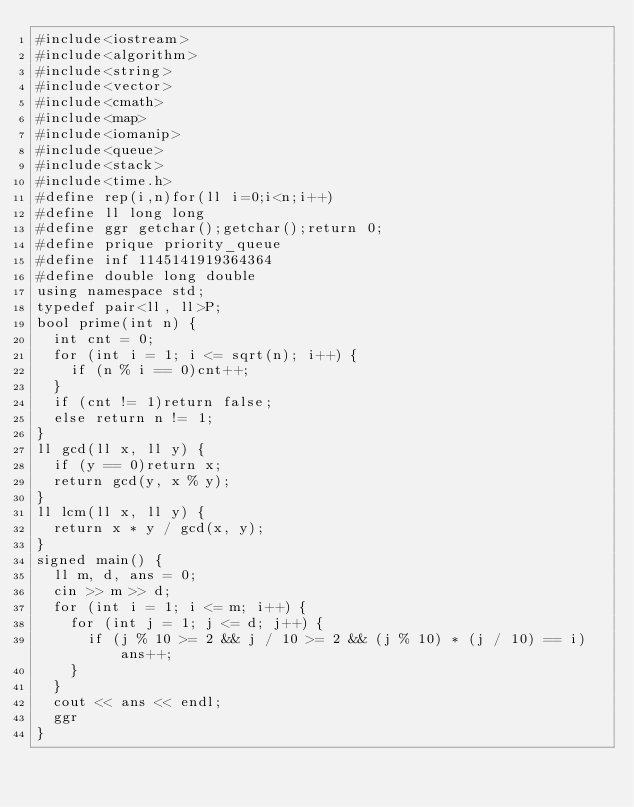<code> <loc_0><loc_0><loc_500><loc_500><_C++_>#include<iostream>
#include<algorithm>
#include<string>
#include<vector>
#include<cmath>
#include<map>
#include<iomanip>
#include<queue>
#include<stack>
#include<time.h>
#define rep(i,n)for(ll i=0;i<n;i++)
#define ll long long
#define ggr getchar();getchar();return 0;
#define prique priority_queue
#define inf 1145141919364364
#define double long double
using namespace std;
typedef pair<ll, ll>P;
bool prime(int n) {
	int cnt = 0;
	for (int i = 1; i <= sqrt(n); i++) {
		if (n % i == 0)cnt++;
	}
	if (cnt != 1)return false;
	else return n != 1;
}
ll gcd(ll x, ll y) {
	if (y == 0)return x;
	return gcd(y, x % y);
}
ll lcm(ll x, ll y) {
	return x * y / gcd(x, y);
}
signed main() {
	ll m, d, ans = 0;
	cin >> m >> d;
	for (int i = 1; i <= m; i++) {
		for (int j = 1; j <= d; j++) {
			if (j % 10 >= 2 && j / 10 >= 2 && (j % 10) * (j / 10) == i)ans++;
		}
	}
	cout << ans << endl;
	ggr
}
</code> 